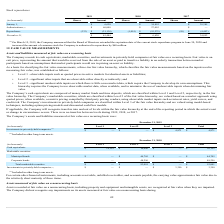According to Pegasystems's financial document, When did the company announce that the Board of Directors extended the expiration date of the current stock repurchase program? According to the financial document, March 15, 2019. The relevant text states: "(1) On March 15, 2019, the Company announced that the Board of Directors extended the expiration date of the current stoc..." Also, What were the amounts that the company is authorised to repurchase in 2019 and 2018 respectively? The document shows two values: $60,000 and $27,003 (in thousands). From the document: "Authorizations (1) $ 60,000 $ 27,003 $ — Authorizations (1) $ 60,000 $ 27,003 $ —..." Also, What were the respective amounts of stock repurchases made by the company as at January 1, 2018 and 2019 respectively? The document shows two values: $34,892 and $6,620 (in thousands). From the document: "January 1, $ 6,620 $ 34,892 $ 39,385 January 1, $ 6,620 $ 34,892 $ 39,385..." Also, can you calculate: What is the value of stock repurchases as at January 1, 2019 as a percentage of the stock repurchases as at January 1, 2018? Based on the calculation: 6,620/34,892 , the result is 18.97 (percentage). This is based on the information: "January 1, $ 6,620 $ 34,892 $ 39,385 January 1, $ 6,620 $ 34,892 $ 39,385..." The key data points involved are: 34,892, 6,620. Also, can you calculate: What is the average stock repurchases as at January 1, 2017 and 2018? To answer this question, I need to perform calculations using the financial data. The calculation is: (39,385 + 34,892)/2 , which equals 37138.5 (in thousands). This is based on the information: "January 1, $ 6,620 $ 34,892 $ 39,385 January 1, $ 6,620 $ 34,892 $ 39,385..." The key data points involved are: 34,892, 39,385. Also, can you calculate: What is the percentage change in stock repurchases authorizations made in 2018 and 2019? To answer this question, I need to perform calculations using the financial data. The calculation is: (60,000 - 27,003)/27,003 , which equals 122.2 (percentage). This is based on the information: "Authorizations (1) $ 60,000 $ 27,003 $ — Authorizations (1) $ 60,000 $ 27,003 $ —..." The key data points involved are: 27,003, 60,000. 